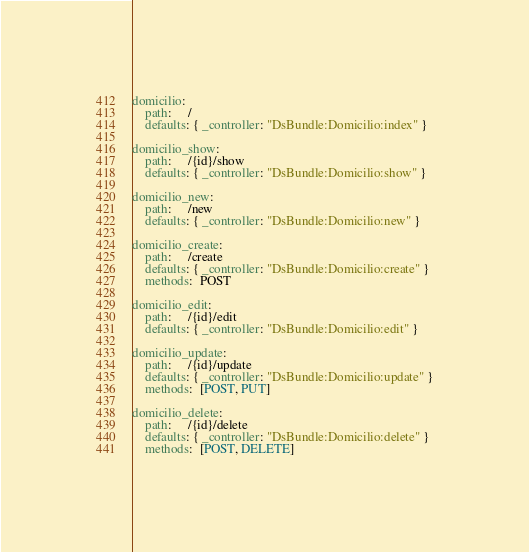<code> <loc_0><loc_0><loc_500><loc_500><_YAML_>domicilio:
    path:     /
    defaults: { _controller: "DsBundle:Domicilio:index" }

domicilio_show:
    path:     /{id}/show
    defaults: { _controller: "DsBundle:Domicilio:show" }

domicilio_new:
    path:     /new
    defaults: { _controller: "DsBundle:Domicilio:new" }

domicilio_create:
    path:     /create
    defaults: { _controller: "DsBundle:Domicilio:create" }
    methods:  POST

domicilio_edit:
    path:     /{id}/edit
    defaults: { _controller: "DsBundle:Domicilio:edit" }

domicilio_update:
    path:     /{id}/update
    defaults: { _controller: "DsBundle:Domicilio:update" }
    methods:  [POST, PUT]

domicilio_delete:
    path:     /{id}/delete
    defaults: { _controller: "DsBundle:Domicilio:delete" }
    methods:  [POST, DELETE]
</code> 